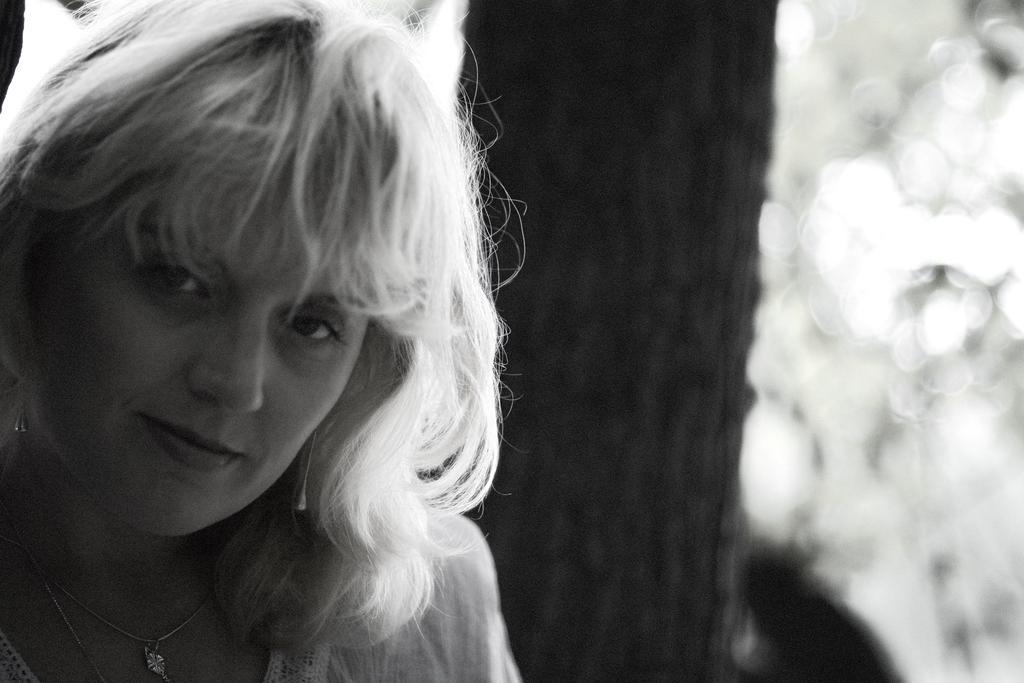In one or two sentences, can you explain what this image depicts? In this image there is a woman with a smile on her face, this is a black and white image. 